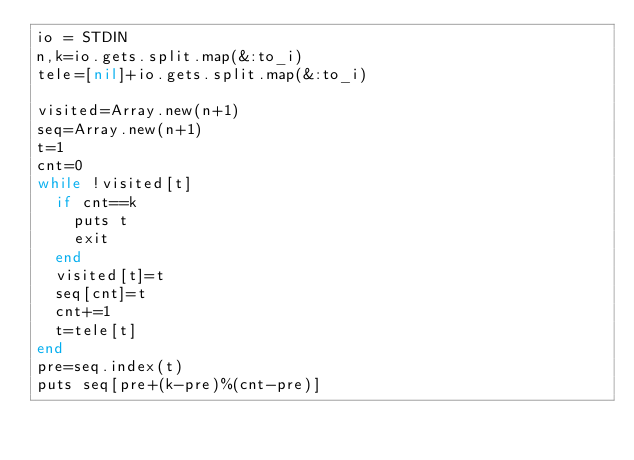<code> <loc_0><loc_0><loc_500><loc_500><_Ruby_>io = STDIN
n,k=io.gets.split.map(&:to_i)
tele=[nil]+io.gets.split.map(&:to_i)

visited=Array.new(n+1)
seq=Array.new(n+1)
t=1
cnt=0
while !visited[t]
  if cnt==k
    puts t
    exit
  end
  visited[t]=t
  seq[cnt]=t
  cnt+=1
  t=tele[t]
end
pre=seq.index(t)
puts seq[pre+(k-pre)%(cnt-pre)]
</code> 